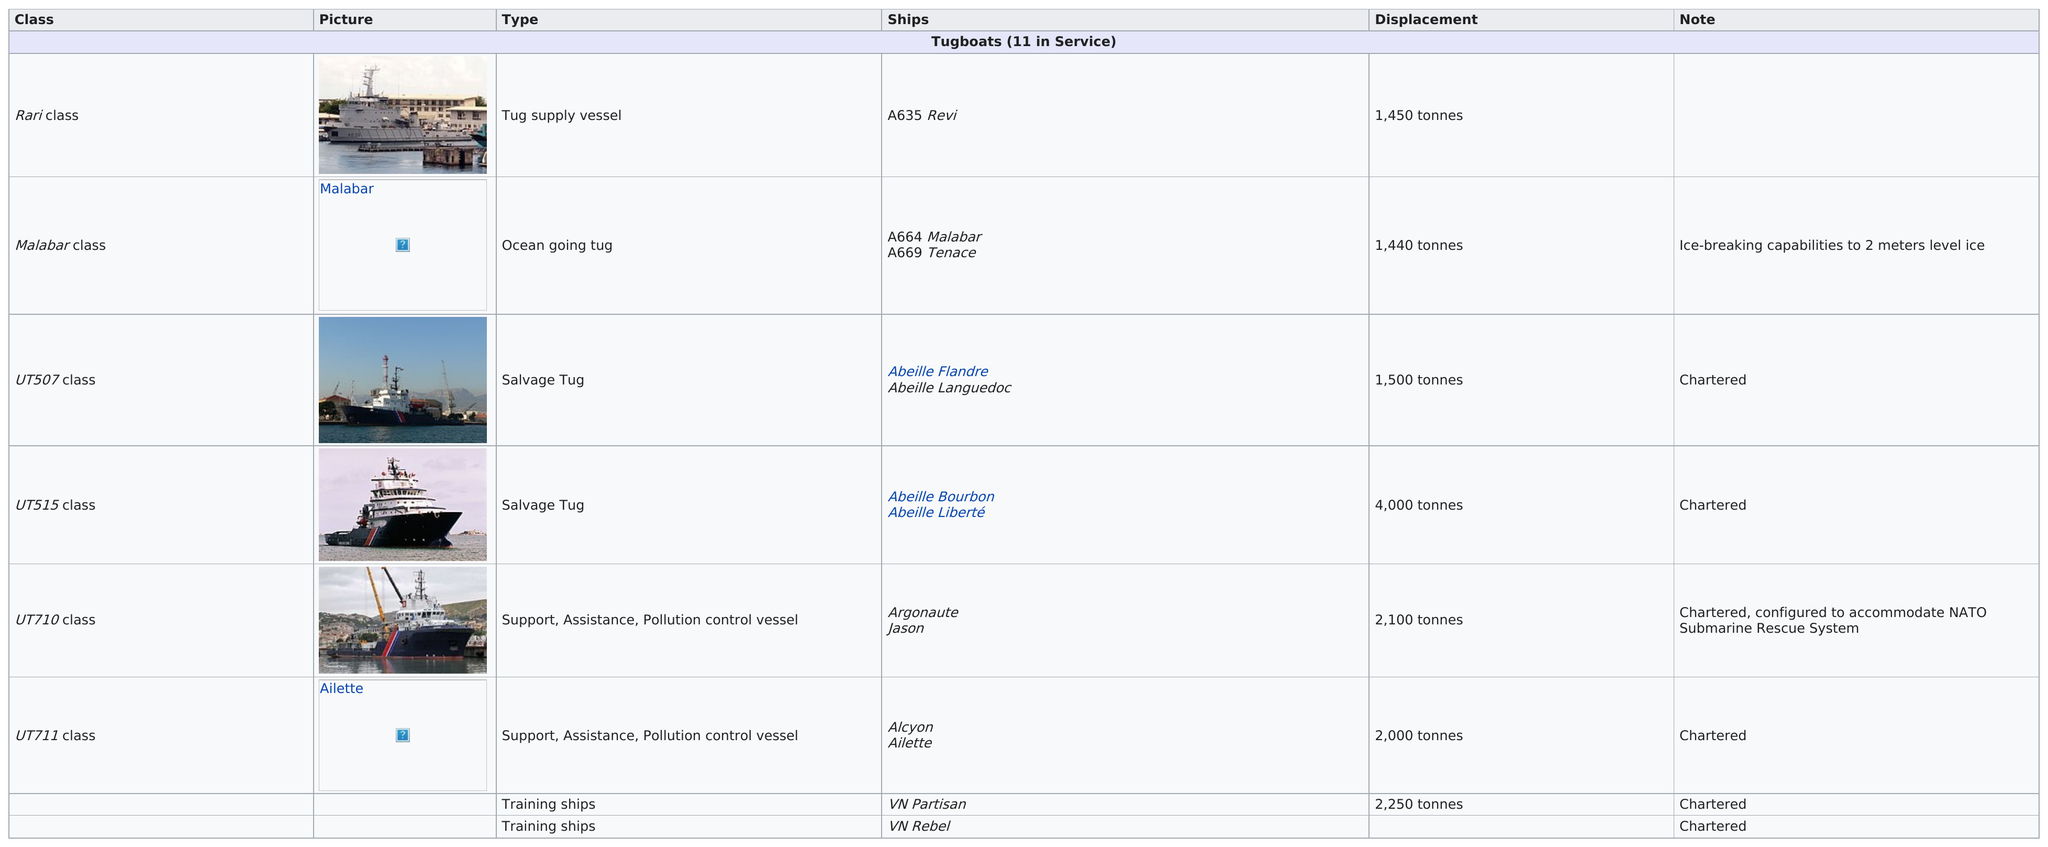Identify some key points in this picture. There are six total tugboats pictured. There are four tugboats that are at least 1,600 tonnes in size. The Malabar class has the least displacement in tonnes. The Malabar class and the UT507 class have differences in tonnage, with the Malabar class having a tonnage of 60 while the UT507 class has a tonnage of 507. The UT710 class tug is the only one that is configured to accommodate NATO. 